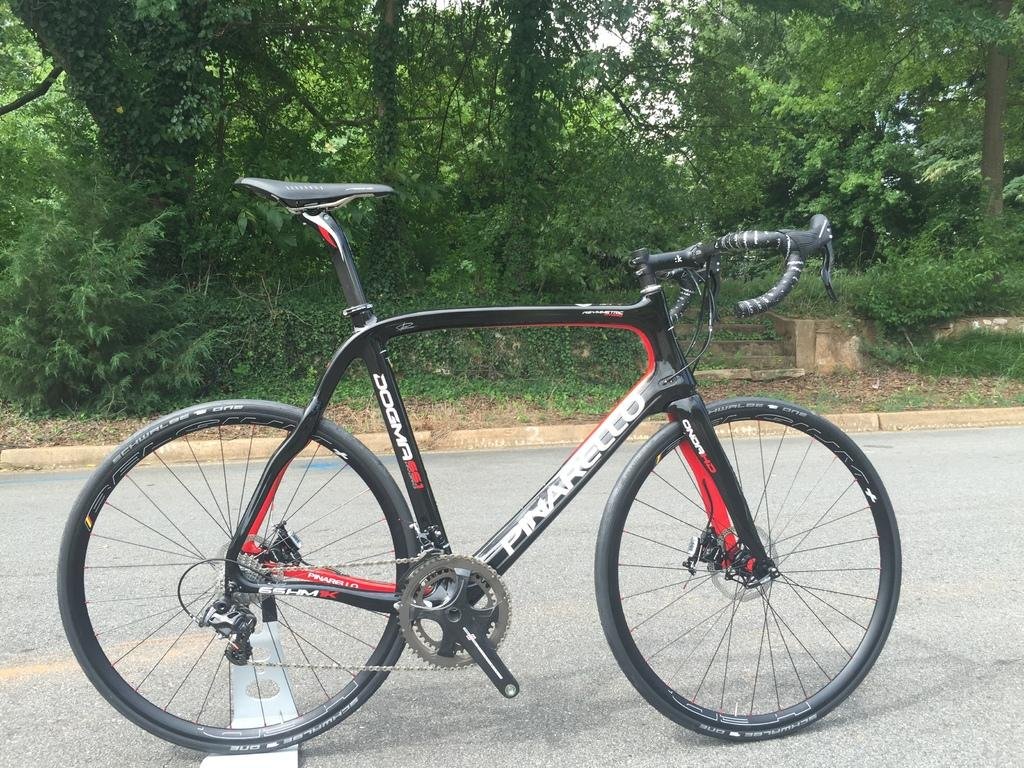What is on the road in the image? There is a bicycle on the road in the image. What type of vegetation can be seen in the image? Trees and plants are present in the image. What type of glass can be seen on the mountain in the image? There is no mountain or glass present in the image. How does the person in the image look after getting a haircut? There is no person in the image, so it's not possible to determine how they look after getting a haircut. 